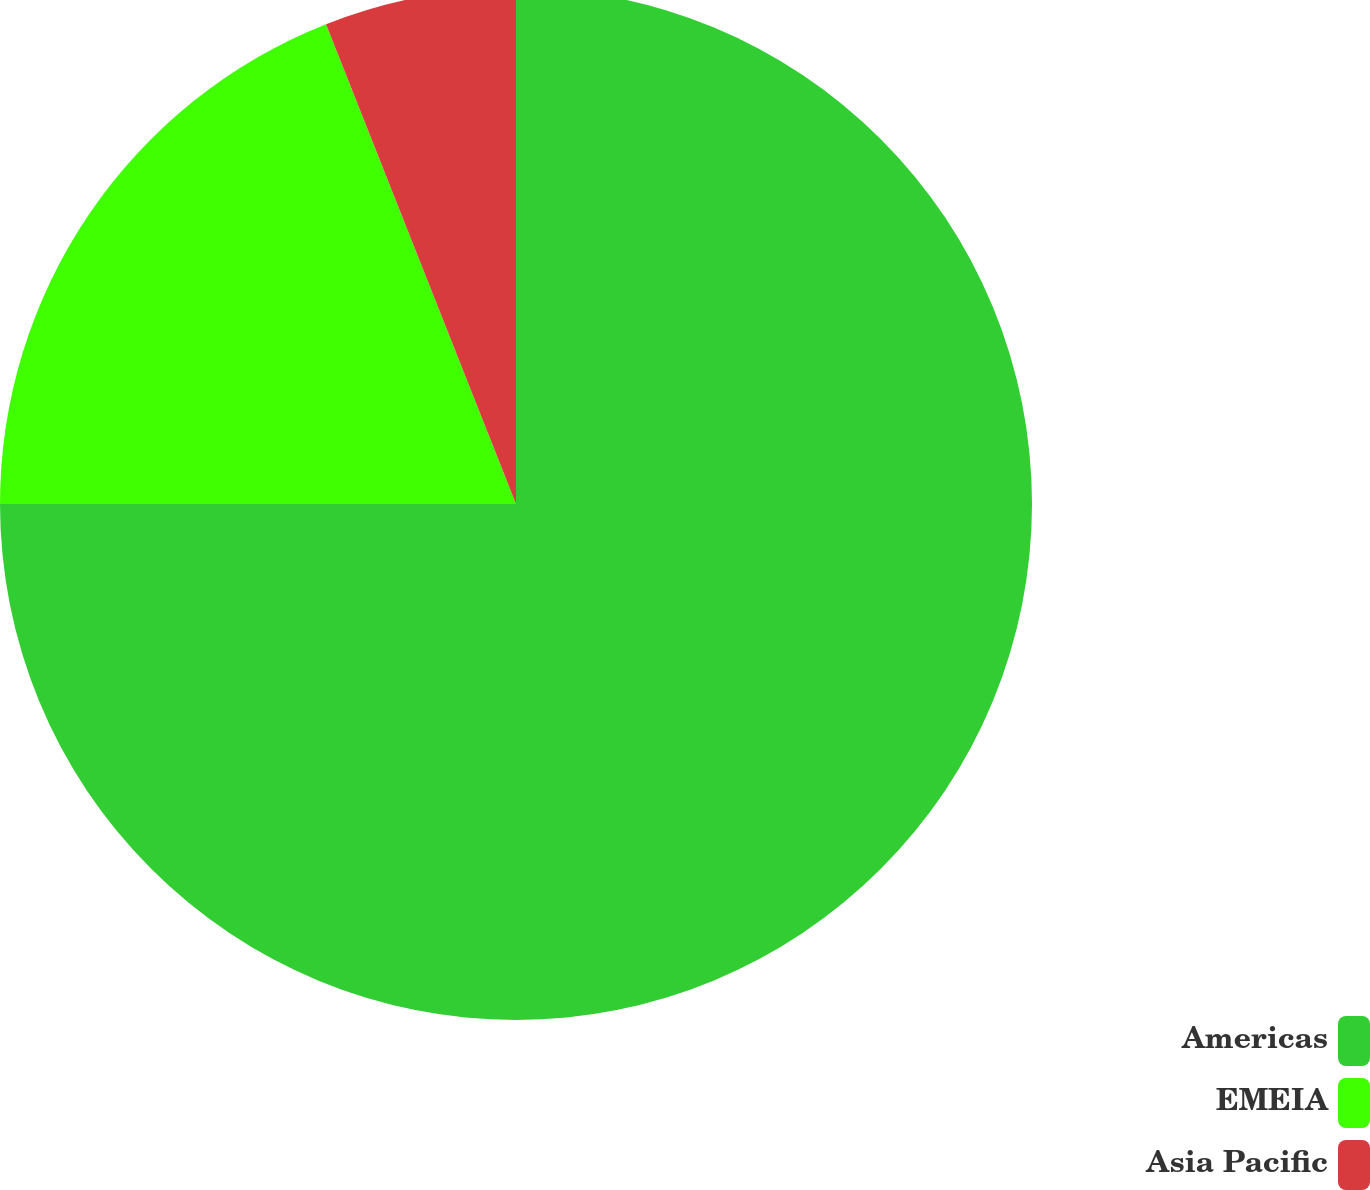Convert chart. <chart><loc_0><loc_0><loc_500><loc_500><pie_chart><fcel>Americas<fcel>EMEIA<fcel>Asia Pacific<nl><fcel>75.0%<fcel>19.0%<fcel>6.0%<nl></chart> 